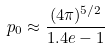Convert formula to latex. <formula><loc_0><loc_0><loc_500><loc_500>p _ { 0 } \approx \frac { ( 4 \pi ) ^ { 5 / 2 } } { 1 . 4 e - 1 }</formula> 